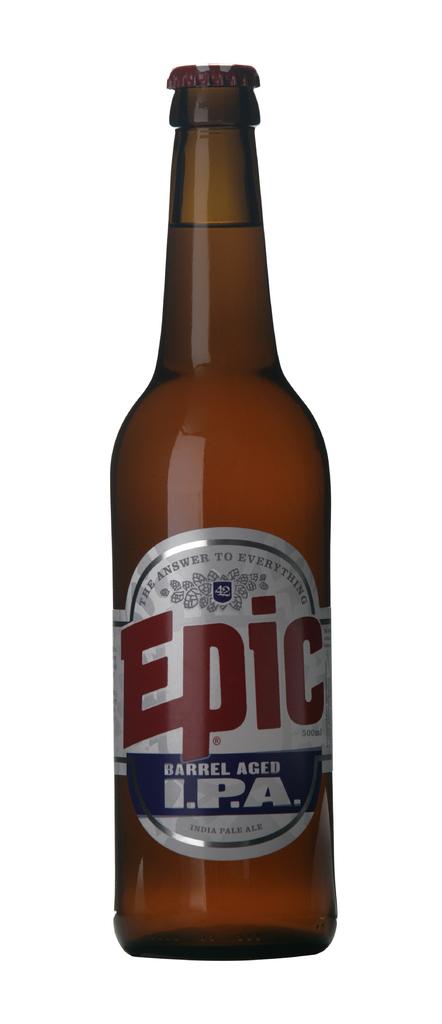What style of beer is in the bottle?
Your answer should be compact. Ipa. What name is on the bottle?
Keep it short and to the point. Epic. 